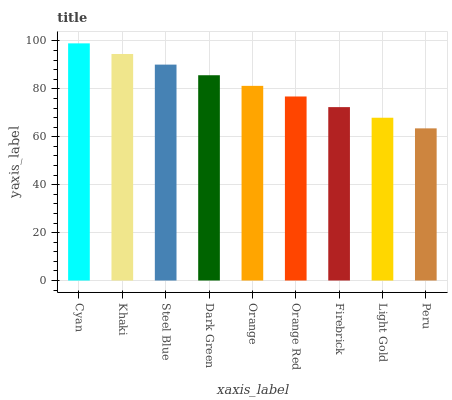Is Peru the minimum?
Answer yes or no. Yes. Is Cyan the maximum?
Answer yes or no. Yes. Is Khaki the minimum?
Answer yes or no. No. Is Khaki the maximum?
Answer yes or no. No. Is Cyan greater than Khaki?
Answer yes or no. Yes. Is Khaki less than Cyan?
Answer yes or no. Yes. Is Khaki greater than Cyan?
Answer yes or no. No. Is Cyan less than Khaki?
Answer yes or no. No. Is Orange the high median?
Answer yes or no. Yes. Is Orange the low median?
Answer yes or no. Yes. Is Steel Blue the high median?
Answer yes or no. No. Is Cyan the low median?
Answer yes or no. No. 